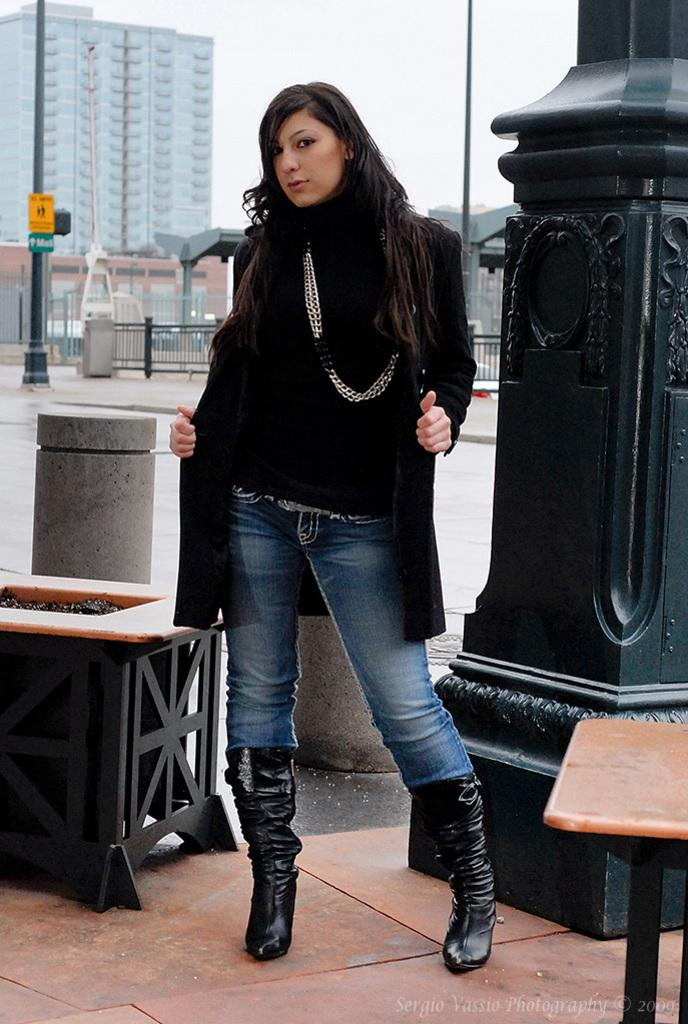What is the main subject of the image? There is a woman standing in the image. What is the woman doing in the image? The woman is giving a pose. Can you describe the woman's hand position in the image? The woman has her hand behind her. What can be seen in the background of the image? There is a building visible in the background. What other object is present in the image? There is a pole in the image. How many eyes does the carriage have in the image? There is no carriage present in the image, so it is not possible to determine the number of eyes it might have. 